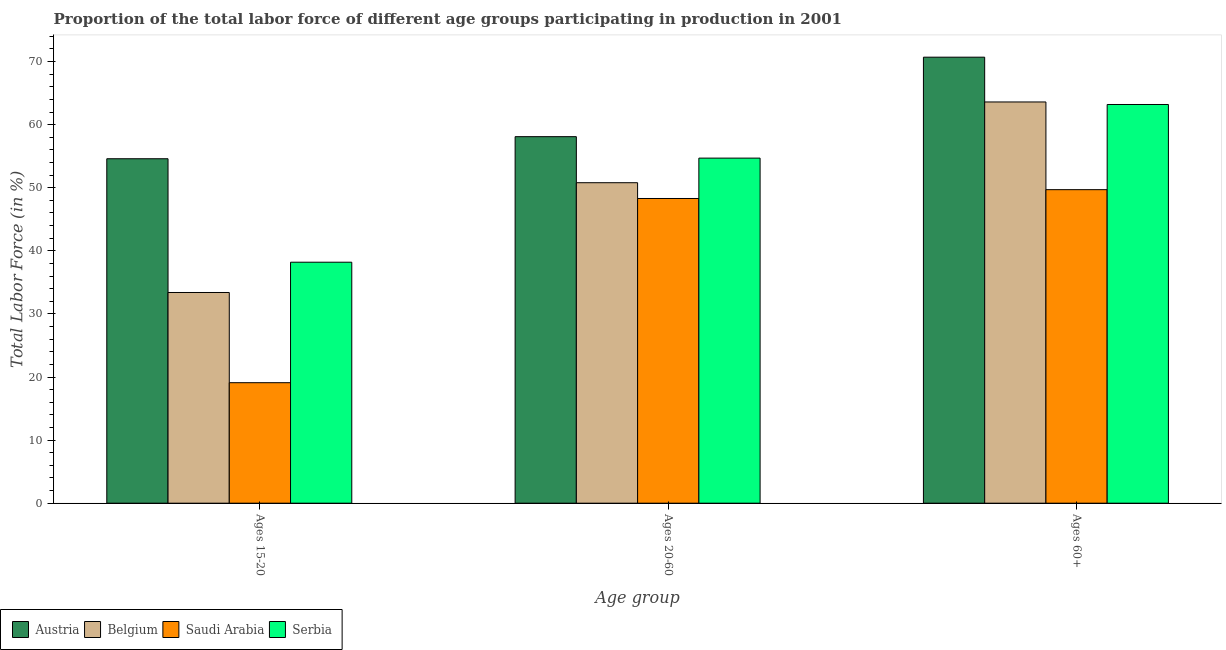How many different coloured bars are there?
Keep it short and to the point. 4. How many groups of bars are there?
Your answer should be compact. 3. Are the number of bars per tick equal to the number of legend labels?
Make the answer very short. Yes. How many bars are there on the 2nd tick from the left?
Your answer should be compact. 4. What is the label of the 3rd group of bars from the left?
Provide a succinct answer. Ages 60+. What is the percentage of labor force above age 60 in Saudi Arabia?
Offer a terse response. 49.7. Across all countries, what is the maximum percentage of labor force within the age group 20-60?
Make the answer very short. 58.1. Across all countries, what is the minimum percentage of labor force within the age group 20-60?
Your answer should be very brief. 48.3. In which country was the percentage of labor force above age 60 minimum?
Offer a terse response. Saudi Arabia. What is the total percentage of labor force above age 60 in the graph?
Give a very brief answer. 247.2. What is the difference between the percentage of labor force within the age group 20-60 in Belgium and that in Austria?
Give a very brief answer. -7.3. What is the difference between the percentage of labor force within the age group 20-60 in Belgium and the percentage of labor force within the age group 15-20 in Austria?
Offer a very short reply. -3.8. What is the average percentage of labor force within the age group 15-20 per country?
Offer a very short reply. 36.33. In how many countries, is the percentage of labor force within the age group 15-20 greater than 72 %?
Your answer should be very brief. 0. What is the ratio of the percentage of labor force above age 60 in Saudi Arabia to that in Serbia?
Ensure brevity in your answer.  0.79. What is the difference between the highest and the second highest percentage of labor force within the age group 15-20?
Provide a succinct answer. 16.4. What is the difference between the highest and the lowest percentage of labor force within the age group 15-20?
Offer a very short reply. 35.5. In how many countries, is the percentage of labor force within the age group 20-60 greater than the average percentage of labor force within the age group 20-60 taken over all countries?
Provide a short and direct response. 2. Is the sum of the percentage of labor force within the age group 20-60 in Serbia and Austria greater than the maximum percentage of labor force within the age group 15-20 across all countries?
Your answer should be compact. Yes. What does the 3rd bar from the left in Ages 15-20 represents?
Offer a terse response. Saudi Arabia. What does the 1st bar from the right in Ages 15-20 represents?
Ensure brevity in your answer.  Serbia. Is it the case that in every country, the sum of the percentage of labor force within the age group 15-20 and percentage of labor force within the age group 20-60 is greater than the percentage of labor force above age 60?
Offer a terse response. Yes. How many bars are there?
Give a very brief answer. 12. Are all the bars in the graph horizontal?
Your answer should be very brief. No. How many countries are there in the graph?
Give a very brief answer. 4. Are the values on the major ticks of Y-axis written in scientific E-notation?
Your response must be concise. No. Does the graph contain grids?
Offer a terse response. No. How many legend labels are there?
Your answer should be very brief. 4. What is the title of the graph?
Give a very brief answer. Proportion of the total labor force of different age groups participating in production in 2001. Does "Finland" appear as one of the legend labels in the graph?
Ensure brevity in your answer.  No. What is the label or title of the X-axis?
Offer a terse response. Age group. What is the label or title of the Y-axis?
Ensure brevity in your answer.  Total Labor Force (in %). What is the Total Labor Force (in %) of Austria in Ages 15-20?
Provide a short and direct response. 54.6. What is the Total Labor Force (in %) in Belgium in Ages 15-20?
Provide a short and direct response. 33.4. What is the Total Labor Force (in %) of Saudi Arabia in Ages 15-20?
Offer a terse response. 19.1. What is the Total Labor Force (in %) of Serbia in Ages 15-20?
Your response must be concise. 38.2. What is the Total Labor Force (in %) in Austria in Ages 20-60?
Provide a short and direct response. 58.1. What is the Total Labor Force (in %) in Belgium in Ages 20-60?
Provide a succinct answer. 50.8. What is the Total Labor Force (in %) of Saudi Arabia in Ages 20-60?
Provide a succinct answer. 48.3. What is the Total Labor Force (in %) in Serbia in Ages 20-60?
Offer a very short reply. 54.7. What is the Total Labor Force (in %) of Austria in Ages 60+?
Provide a short and direct response. 70.7. What is the Total Labor Force (in %) in Belgium in Ages 60+?
Give a very brief answer. 63.6. What is the Total Labor Force (in %) in Saudi Arabia in Ages 60+?
Offer a very short reply. 49.7. What is the Total Labor Force (in %) of Serbia in Ages 60+?
Ensure brevity in your answer.  63.2. Across all Age group, what is the maximum Total Labor Force (in %) of Austria?
Keep it short and to the point. 70.7. Across all Age group, what is the maximum Total Labor Force (in %) of Belgium?
Your answer should be compact. 63.6. Across all Age group, what is the maximum Total Labor Force (in %) of Saudi Arabia?
Offer a terse response. 49.7. Across all Age group, what is the maximum Total Labor Force (in %) of Serbia?
Your answer should be compact. 63.2. Across all Age group, what is the minimum Total Labor Force (in %) of Austria?
Keep it short and to the point. 54.6. Across all Age group, what is the minimum Total Labor Force (in %) in Belgium?
Offer a terse response. 33.4. Across all Age group, what is the minimum Total Labor Force (in %) in Saudi Arabia?
Your answer should be very brief. 19.1. Across all Age group, what is the minimum Total Labor Force (in %) in Serbia?
Your answer should be very brief. 38.2. What is the total Total Labor Force (in %) in Austria in the graph?
Make the answer very short. 183.4. What is the total Total Labor Force (in %) of Belgium in the graph?
Provide a succinct answer. 147.8. What is the total Total Labor Force (in %) of Saudi Arabia in the graph?
Provide a succinct answer. 117.1. What is the total Total Labor Force (in %) in Serbia in the graph?
Offer a terse response. 156.1. What is the difference between the Total Labor Force (in %) in Belgium in Ages 15-20 and that in Ages 20-60?
Provide a short and direct response. -17.4. What is the difference between the Total Labor Force (in %) in Saudi Arabia in Ages 15-20 and that in Ages 20-60?
Your answer should be compact. -29.2. What is the difference between the Total Labor Force (in %) of Serbia in Ages 15-20 and that in Ages 20-60?
Make the answer very short. -16.5. What is the difference between the Total Labor Force (in %) in Austria in Ages 15-20 and that in Ages 60+?
Your answer should be very brief. -16.1. What is the difference between the Total Labor Force (in %) of Belgium in Ages 15-20 and that in Ages 60+?
Keep it short and to the point. -30.2. What is the difference between the Total Labor Force (in %) in Saudi Arabia in Ages 15-20 and that in Ages 60+?
Offer a very short reply. -30.6. What is the difference between the Total Labor Force (in %) of Serbia in Ages 15-20 and that in Ages 60+?
Ensure brevity in your answer.  -25. What is the difference between the Total Labor Force (in %) of Austria in Ages 20-60 and that in Ages 60+?
Your answer should be very brief. -12.6. What is the difference between the Total Labor Force (in %) in Serbia in Ages 20-60 and that in Ages 60+?
Make the answer very short. -8.5. What is the difference between the Total Labor Force (in %) in Belgium in Ages 15-20 and the Total Labor Force (in %) in Saudi Arabia in Ages 20-60?
Your response must be concise. -14.9. What is the difference between the Total Labor Force (in %) in Belgium in Ages 15-20 and the Total Labor Force (in %) in Serbia in Ages 20-60?
Provide a succinct answer. -21.3. What is the difference between the Total Labor Force (in %) in Saudi Arabia in Ages 15-20 and the Total Labor Force (in %) in Serbia in Ages 20-60?
Your answer should be very brief. -35.6. What is the difference between the Total Labor Force (in %) of Belgium in Ages 15-20 and the Total Labor Force (in %) of Saudi Arabia in Ages 60+?
Ensure brevity in your answer.  -16.3. What is the difference between the Total Labor Force (in %) of Belgium in Ages 15-20 and the Total Labor Force (in %) of Serbia in Ages 60+?
Keep it short and to the point. -29.8. What is the difference between the Total Labor Force (in %) of Saudi Arabia in Ages 15-20 and the Total Labor Force (in %) of Serbia in Ages 60+?
Give a very brief answer. -44.1. What is the difference between the Total Labor Force (in %) in Austria in Ages 20-60 and the Total Labor Force (in %) in Serbia in Ages 60+?
Your answer should be compact. -5.1. What is the difference between the Total Labor Force (in %) of Belgium in Ages 20-60 and the Total Labor Force (in %) of Saudi Arabia in Ages 60+?
Give a very brief answer. 1.1. What is the difference between the Total Labor Force (in %) in Belgium in Ages 20-60 and the Total Labor Force (in %) in Serbia in Ages 60+?
Provide a succinct answer. -12.4. What is the difference between the Total Labor Force (in %) in Saudi Arabia in Ages 20-60 and the Total Labor Force (in %) in Serbia in Ages 60+?
Provide a short and direct response. -14.9. What is the average Total Labor Force (in %) in Austria per Age group?
Provide a short and direct response. 61.13. What is the average Total Labor Force (in %) of Belgium per Age group?
Provide a succinct answer. 49.27. What is the average Total Labor Force (in %) in Saudi Arabia per Age group?
Your response must be concise. 39.03. What is the average Total Labor Force (in %) of Serbia per Age group?
Your answer should be compact. 52.03. What is the difference between the Total Labor Force (in %) in Austria and Total Labor Force (in %) in Belgium in Ages 15-20?
Your response must be concise. 21.2. What is the difference between the Total Labor Force (in %) in Austria and Total Labor Force (in %) in Saudi Arabia in Ages 15-20?
Your response must be concise. 35.5. What is the difference between the Total Labor Force (in %) of Saudi Arabia and Total Labor Force (in %) of Serbia in Ages 15-20?
Offer a terse response. -19.1. What is the difference between the Total Labor Force (in %) of Austria and Total Labor Force (in %) of Belgium in Ages 20-60?
Make the answer very short. 7.3. What is the difference between the Total Labor Force (in %) in Austria and Total Labor Force (in %) in Saudi Arabia in Ages 20-60?
Keep it short and to the point. 9.8. What is the difference between the Total Labor Force (in %) of Austria and Total Labor Force (in %) of Serbia in Ages 20-60?
Provide a short and direct response. 3.4. What is the difference between the Total Labor Force (in %) of Belgium and Total Labor Force (in %) of Serbia in Ages 20-60?
Give a very brief answer. -3.9. What is the ratio of the Total Labor Force (in %) of Austria in Ages 15-20 to that in Ages 20-60?
Offer a very short reply. 0.94. What is the ratio of the Total Labor Force (in %) in Belgium in Ages 15-20 to that in Ages 20-60?
Offer a terse response. 0.66. What is the ratio of the Total Labor Force (in %) of Saudi Arabia in Ages 15-20 to that in Ages 20-60?
Keep it short and to the point. 0.4. What is the ratio of the Total Labor Force (in %) in Serbia in Ages 15-20 to that in Ages 20-60?
Ensure brevity in your answer.  0.7. What is the ratio of the Total Labor Force (in %) of Austria in Ages 15-20 to that in Ages 60+?
Provide a succinct answer. 0.77. What is the ratio of the Total Labor Force (in %) of Belgium in Ages 15-20 to that in Ages 60+?
Your answer should be compact. 0.53. What is the ratio of the Total Labor Force (in %) in Saudi Arabia in Ages 15-20 to that in Ages 60+?
Your response must be concise. 0.38. What is the ratio of the Total Labor Force (in %) of Serbia in Ages 15-20 to that in Ages 60+?
Ensure brevity in your answer.  0.6. What is the ratio of the Total Labor Force (in %) of Austria in Ages 20-60 to that in Ages 60+?
Your response must be concise. 0.82. What is the ratio of the Total Labor Force (in %) in Belgium in Ages 20-60 to that in Ages 60+?
Your answer should be compact. 0.8. What is the ratio of the Total Labor Force (in %) of Saudi Arabia in Ages 20-60 to that in Ages 60+?
Keep it short and to the point. 0.97. What is the ratio of the Total Labor Force (in %) of Serbia in Ages 20-60 to that in Ages 60+?
Provide a succinct answer. 0.87. What is the difference between the highest and the second highest Total Labor Force (in %) of Austria?
Make the answer very short. 12.6. What is the difference between the highest and the lowest Total Labor Force (in %) in Austria?
Your answer should be very brief. 16.1. What is the difference between the highest and the lowest Total Labor Force (in %) of Belgium?
Offer a very short reply. 30.2. What is the difference between the highest and the lowest Total Labor Force (in %) of Saudi Arabia?
Provide a short and direct response. 30.6. What is the difference between the highest and the lowest Total Labor Force (in %) in Serbia?
Make the answer very short. 25. 